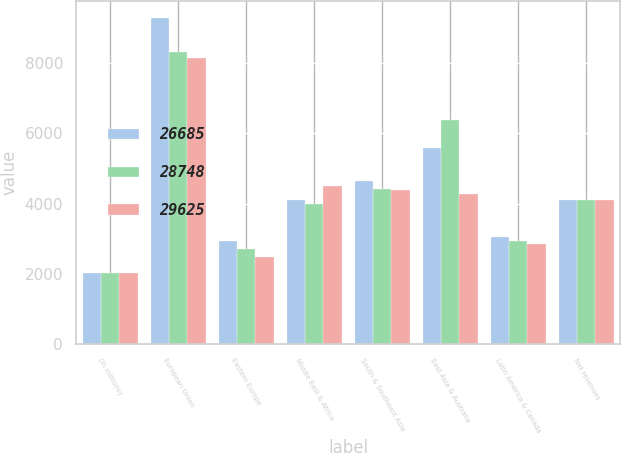Convert chart to OTSL. <chart><loc_0><loc_0><loc_500><loc_500><stacked_bar_chart><ecel><fcel>(in millions)<fcel>European Union<fcel>Eastern Europe<fcel>Middle East & Africa<fcel>South & Southeast Asia<fcel>East Asia & Australia<fcel>Latin America & Canada<fcel>Net revenues<nl><fcel>26685<fcel>2018<fcel>9298<fcel>2921<fcel>4114<fcel>4656<fcel>5580<fcel>3056<fcel>4114<nl><fcel>28748<fcel>2017<fcel>8318<fcel>2711<fcel>3988<fcel>4417<fcel>6373<fcel>2941<fcel>4114<nl><fcel>29625<fcel>2016<fcel>8162<fcel>2484<fcel>4516<fcel>4396<fcel>4285<fcel>2842<fcel>4114<nl></chart> 